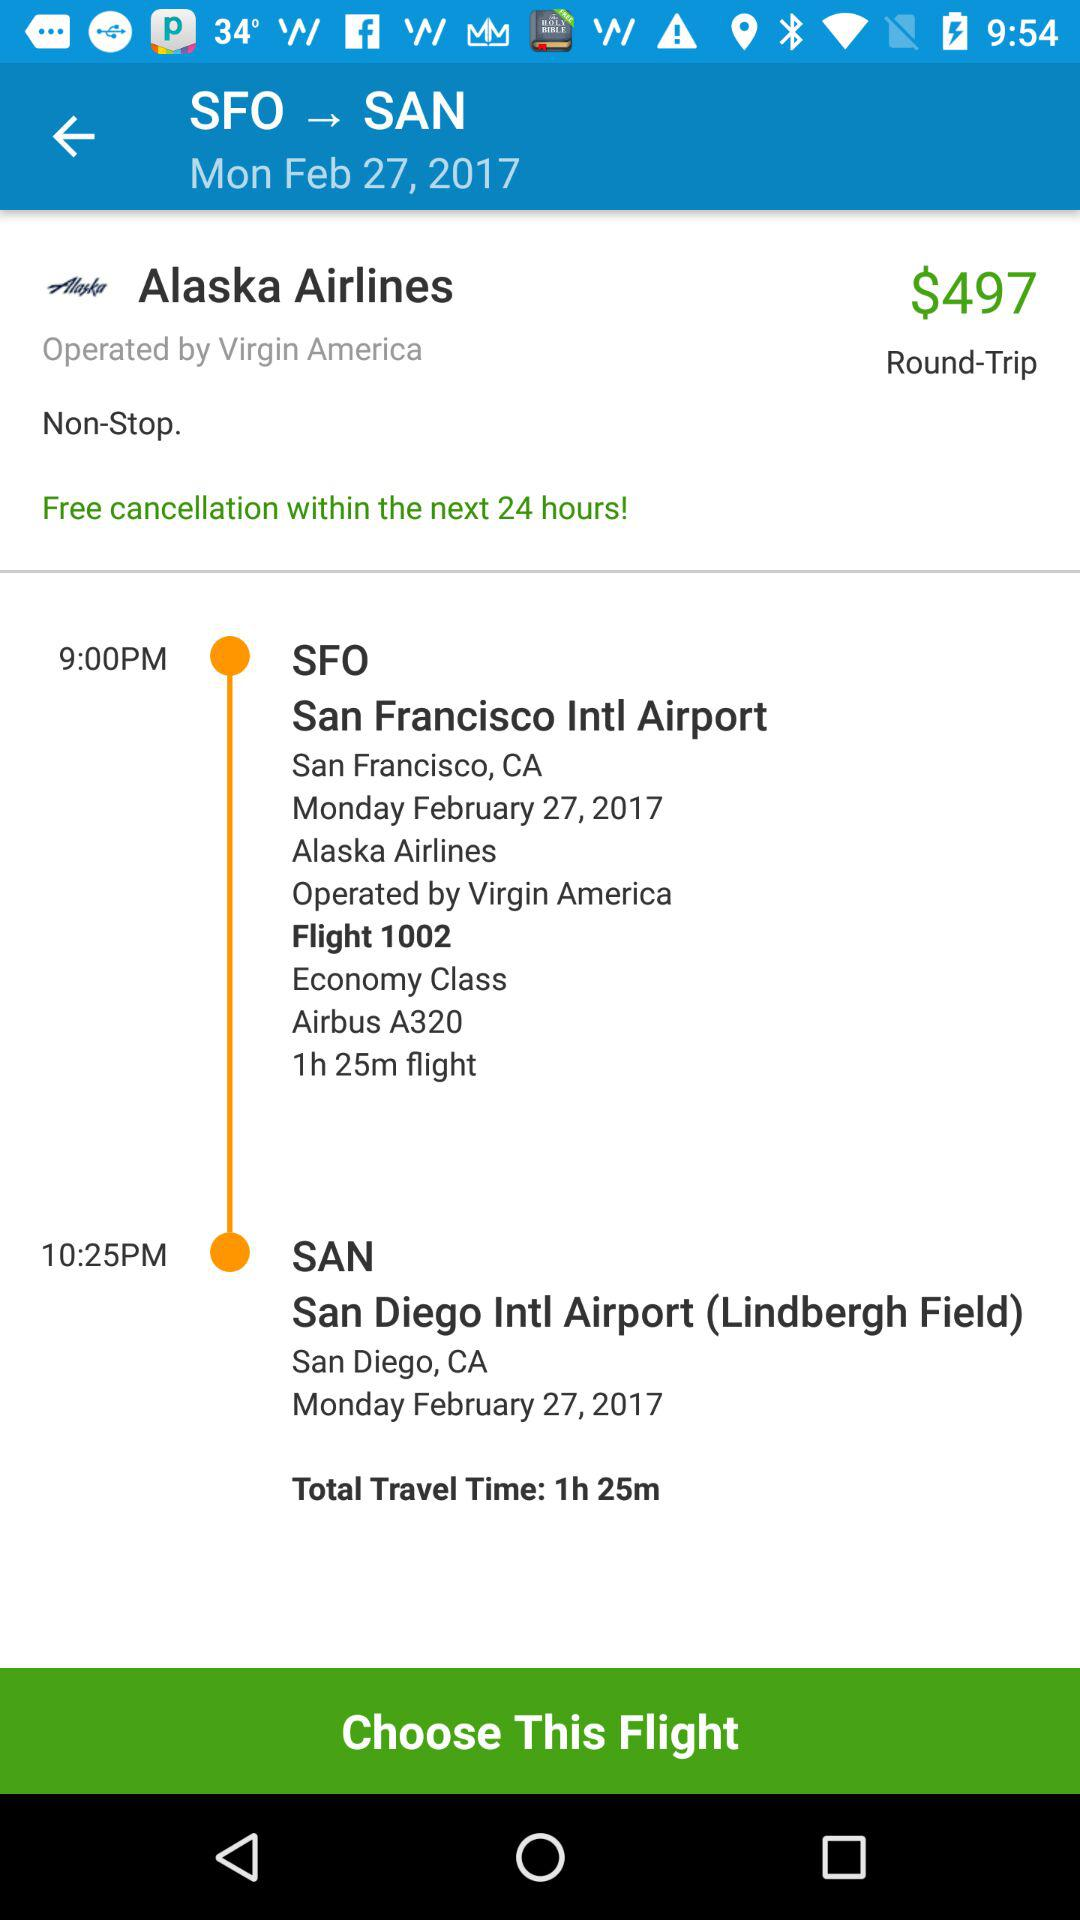What is the total travel time for this flight?
Answer the question using a single word or phrase. 1h 25m 